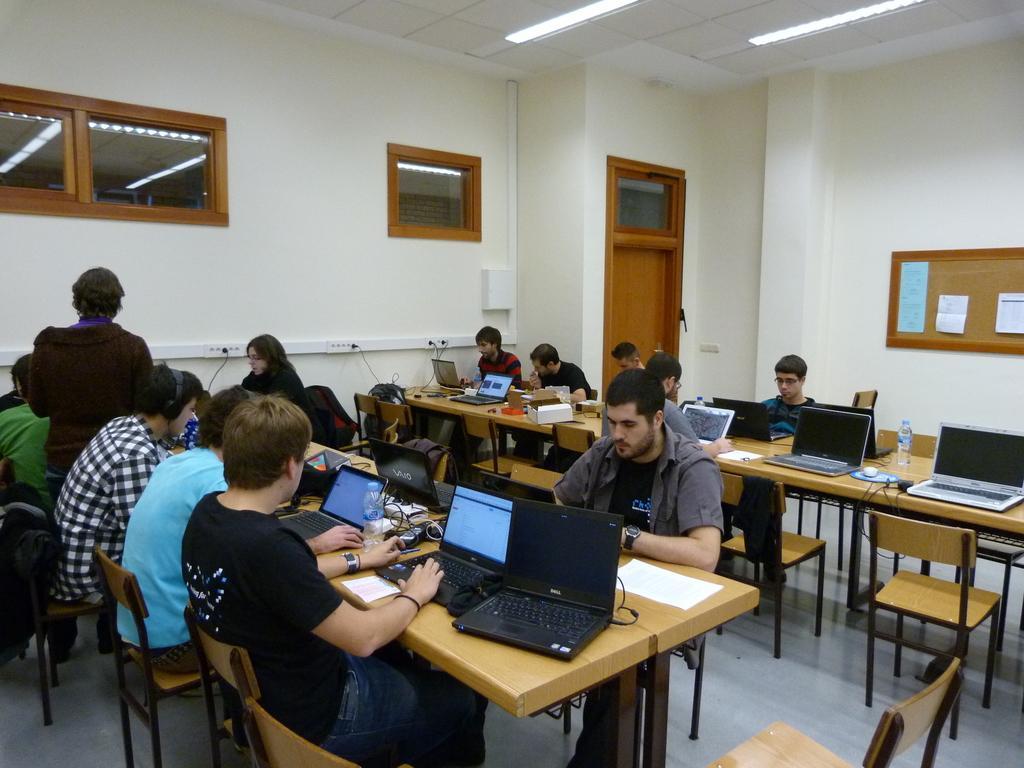Please provide a concise description of this image. In this image we can see people sitting on the chairs and tables are placed in front of them. On the tables there are disposable bottles, cardboard cartons, laptops and cables. In the background we can see electric lights, ventilators, doors, pipelines, charger sockets and a person standing on the floor. 